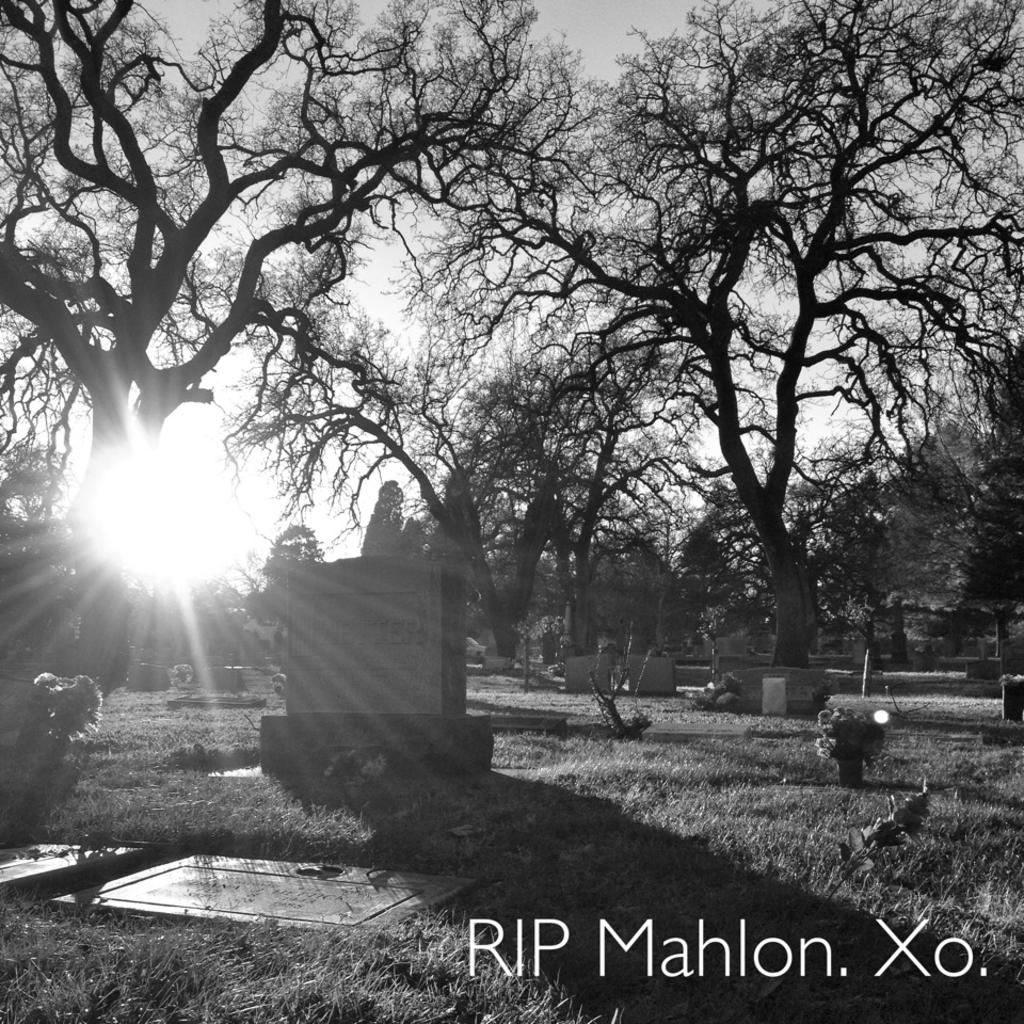What is the color scheme of the image? The image is in black and white. What is the main subject of the image? The image depicts a graveyard. Are there any trees in the graveyard? Yes, there are trees in the graveyard. What is the ground cover in the graveyard? The land in the graveyard is grassy. What can be seen in the sky in the image? The sun is visible in the image. How many parcels are being delivered to the graveyard in the image? There are no parcels or delivery services depicted in the image; it shows a graveyard with trees and grassy land. What thoughts or emotions are being expressed by the mind in the image? There is no representation of a mind or any thoughts or emotions in the image; it is a black and white photograph of a graveyard. 